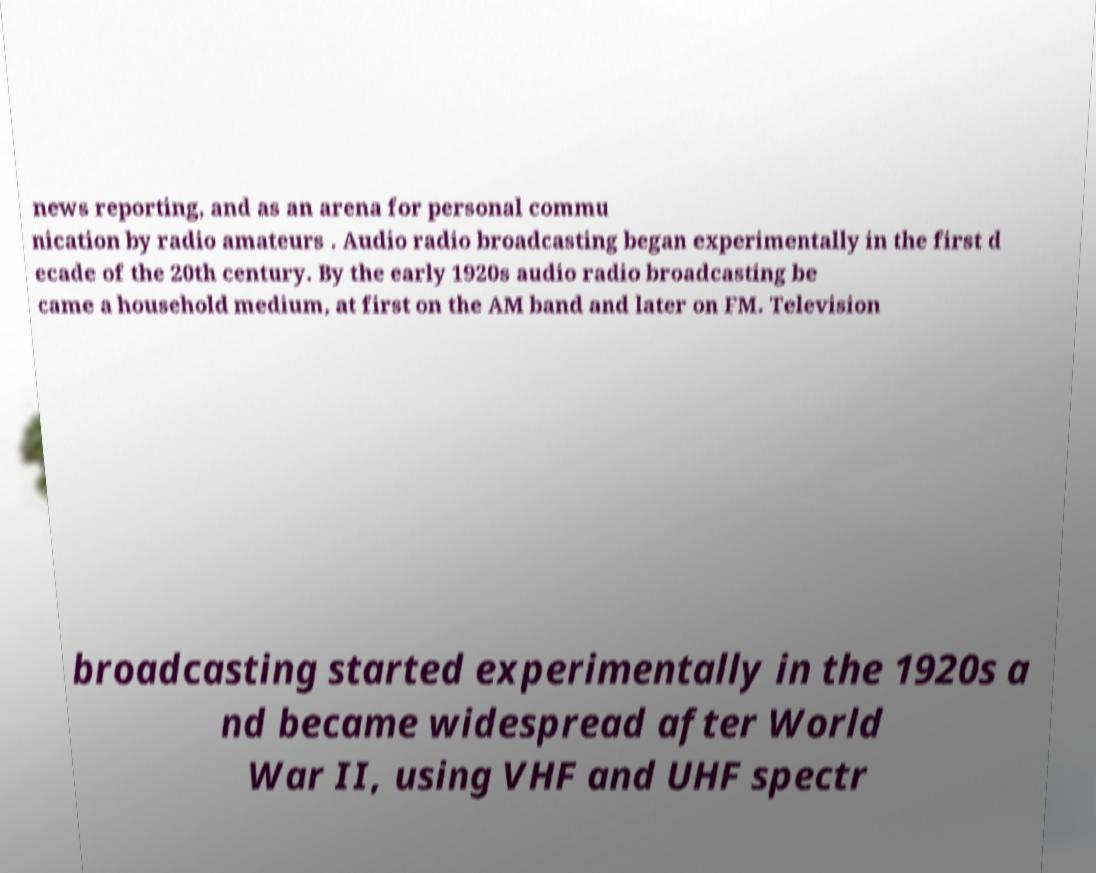For documentation purposes, I need the text within this image transcribed. Could you provide that? news reporting, and as an arena for personal commu nication by radio amateurs . Audio radio broadcasting began experimentally in the first d ecade of the 20th century. By the early 1920s audio radio broadcasting be came a household medium, at first on the AM band and later on FM. Television broadcasting started experimentally in the 1920s a nd became widespread after World War II, using VHF and UHF spectr 